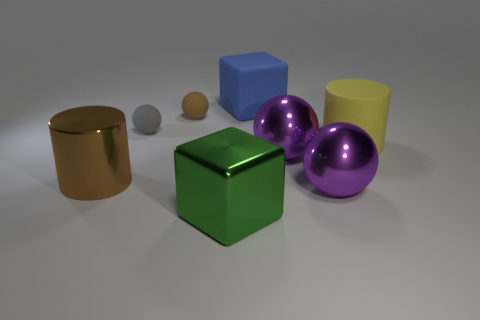Add 1 big objects. How many objects exist? 9 Subtract all cylinders. How many objects are left? 6 Subtract 1 yellow cylinders. How many objects are left? 7 Subtract all tiny blue cylinders. Subtract all gray balls. How many objects are left? 7 Add 3 large blue cubes. How many large blue cubes are left? 4 Add 4 green blocks. How many green blocks exist? 5 